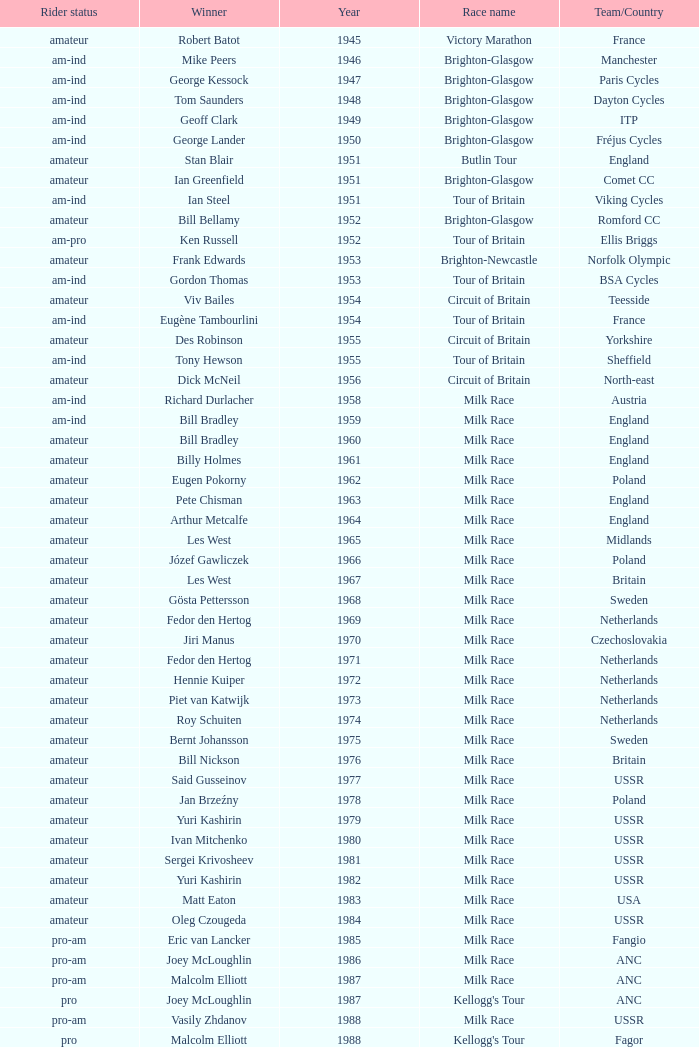What is the latest year when Phil Anderson won? 1993.0. 